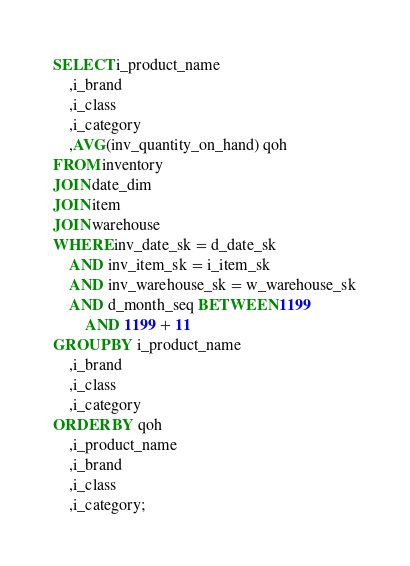Convert code to text. <code><loc_0><loc_0><loc_500><loc_500><_SQL_>SELECT i_product_name
	,i_brand
	,i_class
	,i_category
	,AVG(inv_quantity_on_hand) qoh
FROM inventory
JOIN date_dim
JOIN item
JOIN warehouse
WHERE inv_date_sk = d_date_sk
	AND inv_item_sk = i_item_sk
	AND inv_warehouse_sk = w_warehouse_sk
	AND d_month_seq BETWEEN 1199
		AND 1199 + 11
GROUP BY i_product_name
	,i_brand
	,i_class
	,i_category
ORDER BY qoh
	,i_product_name
	,i_brand
	,i_class
	,i_category;
</code> 